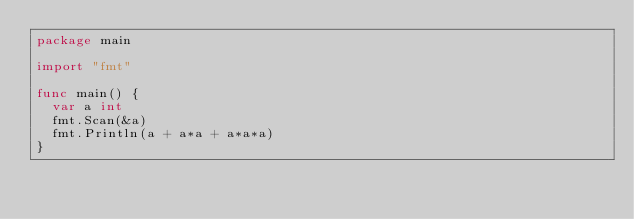Convert code to text. <code><loc_0><loc_0><loc_500><loc_500><_Go_>package main

import "fmt"

func main() {
	var a int
	fmt.Scan(&a)
	fmt.Println(a + a*a + a*a*a)
}
</code> 